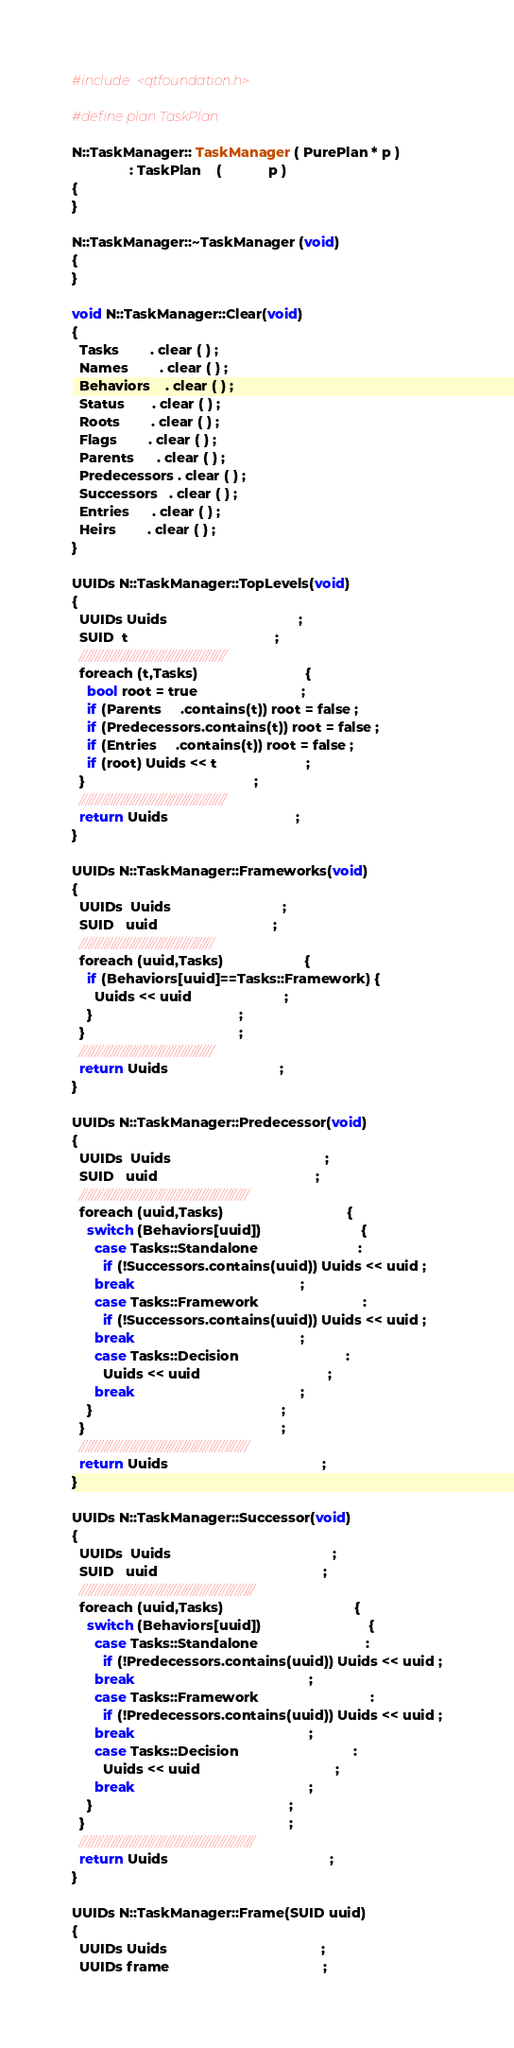<code> <loc_0><loc_0><loc_500><loc_500><_C++_>#include <qtfoundation.h>

#define plan TaskPlan

N::TaskManager:: TaskManager ( PurePlan * p )
               : TaskPlan    (            p )
{
}

N::TaskManager::~TaskManager (void)
{
}

void N::TaskManager::Clear(void)
{
  Tasks        . clear ( ) ;
  Names        . clear ( ) ;
  Behaviors    . clear ( ) ;
  Status       . clear ( ) ;
  Roots        . clear ( ) ;
  Flags        . clear ( ) ;
  Parents      . clear ( ) ;
  Predecessors . clear ( ) ;
  Successors   . clear ( ) ;
  Entries      . clear ( ) ;
  Heirs        . clear ( ) ;
}

UUIDs N::TaskManager::TopLevels(void)
{
  UUIDs Uuids                                  ;
  SUID  t                                      ;
  //////////////////////////////////////////////
  foreach (t,Tasks)                            {
    bool root = true                           ;
    if (Parents     .contains(t)) root = false ;
    if (Predecessors.contains(t)) root = false ;
    if (Entries     .contains(t)) root = false ;
    if (root) Uuids << t                       ;
  }                                            ;
  //////////////////////////////////////////////
  return Uuids                                 ;
}

UUIDs N::TaskManager::Frameworks(void)
{
  UUIDs  Uuids                             ;
  SUID   uuid                              ;
  //////////////////////////////////////////
  foreach (uuid,Tasks)                     {
    if (Behaviors[uuid]==Tasks::Framework) {
      Uuids << uuid                        ;
    }                                      ;
  }                                        ;
  //////////////////////////////////////////
  return Uuids                             ;
}

UUIDs N::TaskManager::Predecessor(void)
{
  UUIDs  Uuids                                        ;
  SUID   uuid                                         ;
  /////////////////////////////////////////////////////
  foreach (uuid,Tasks)                                {
    switch (Behaviors[uuid])                          {
      case Tasks::Standalone                          :
        if (!Successors.contains(uuid)) Uuids << uuid ;
      break                                           ;
      case Tasks::Framework                           :
        if (!Successors.contains(uuid)) Uuids << uuid ;
      break                                           ;
      case Tasks::Decision                            :
        Uuids << uuid                                 ;
      break                                           ;
    }                                                 ;
  }                                                   ;
  /////////////////////////////////////////////////////
  return Uuids                                        ;
}

UUIDs N::TaskManager::Successor(void)
{
  UUIDs  Uuids                                          ;
  SUID   uuid                                           ;
  ///////////////////////////////////////////////////////
  foreach (uuid,Tasks)                                  {
    switch (Behaviors[uuid])                            {
      case Tasks::Standalone                            :
        if (!Predecessors.contains(uuid)) Uuids << uuid ;
      break                                             ;
      case Tasks::Framework                             :
        if (!Predecessors.contains(uuid)) Uuids << uuid ;
      break                                             ;
      case Tasks::Decision                              :
        Uuids << uuid                                   ;
      break                                             ;
    }                                                   ;
  }                                                     ;
  ///////////////////////////////////////////////////////
  return Uuids                                          ;
}

UUIDs N::TaskManager::Frame(SUID uuid)
{
  UUIDs Uuids                                        ;
  UUIDs frame                                        ;</code> 